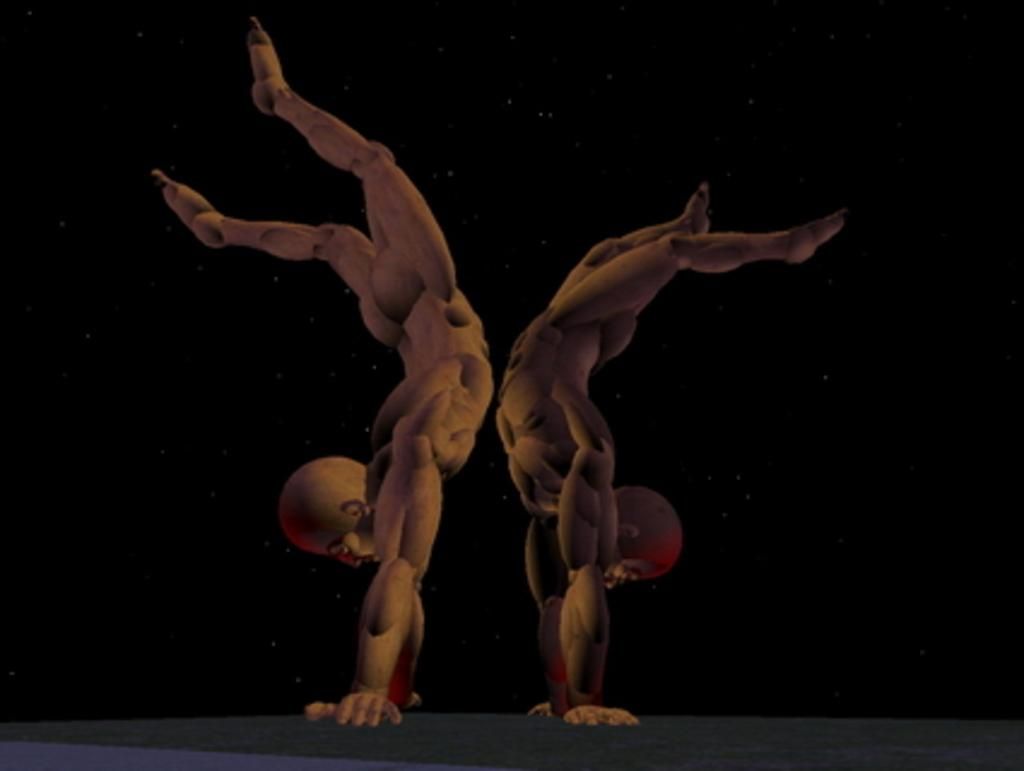What is the main subject of the image? There is a painting in the image. What is happening in the painting? Two persons are depicted in the painting, and they are upside down. What are the persons doing in the painting? The persons are keeping their hands on the land in the painting. What is the color of the background in the painting? The background of the painting is black. Can you tell me how many ladybugs are crawling on the truck in the image? There is no truck or ladybugs present in the image; it features a painting with two upside-down persons. What type of afterthought is shown in the painting? There is no afterthought depicted in the painting; it only shows two persons with their hands on the land. 